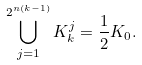<formula> <loc_0><loc_0><loc_500><loc_500>\bigcup _ { j = 1 } ^ { 2 ^ { n ( k - 1 ) } } K _ { k } ^ { j } = \frac { 1 } { 2 } K _ { 0 } .</formula> 